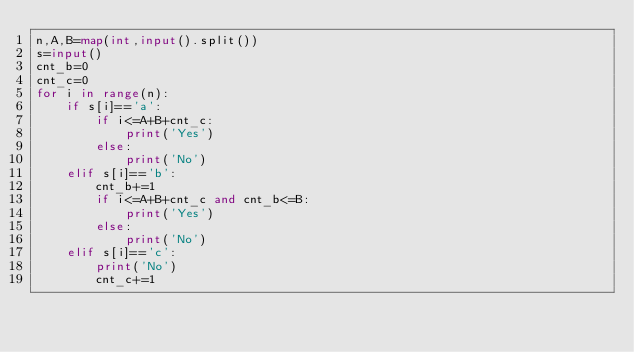Convert code to text. <code><loc_0><loc_0><loc_500><loc_500><_Python_>n,A,B=map(int,input().split())
s=input()
cnt_b=0
cnt_c=0
for i in range(n):
	if s[i]=='a':
		if i<=A+B+cnt_c:
			print('Yes')
		else:
			print('No')
	elif s[i]=='b':
		cnt_b+=1
		if i<=A+B+cnt_c and cnt_b<=B:
			print('Yes')
		else:
			print('No')
	elif s[i]=='c':
		print('No')
		cnt_c+=1</code> 